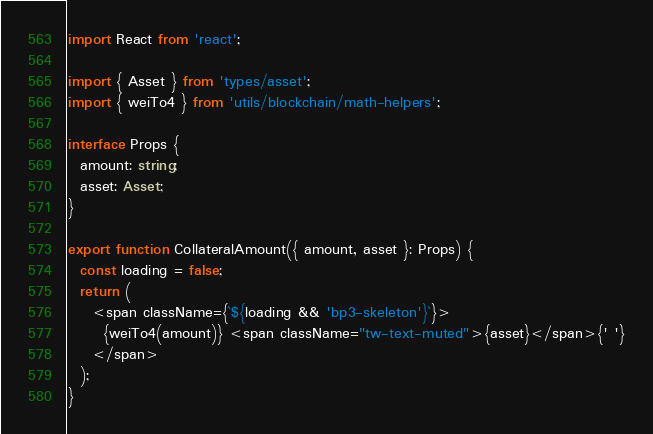<code> <loc_0><loc_0><loc_500><loc_500><_TypeScript_>import React from 'react';

import { Asset } from 'types/asset';
import { weiTo4 } from 'utils/blockchain/math-helpers';

interface Props {
  amount: string;
  asset: Asset;
}

export function CollateralAmount({ amount, asset }: Props) {
  const loading = false;
  return (
    <span className={`${loading && 'bp3-skeleton'}`}>
      {weiTo4(amount)} <span className="tw-text-muted">{asset}</span>{' '}
    </span>
  );
}
</code> 